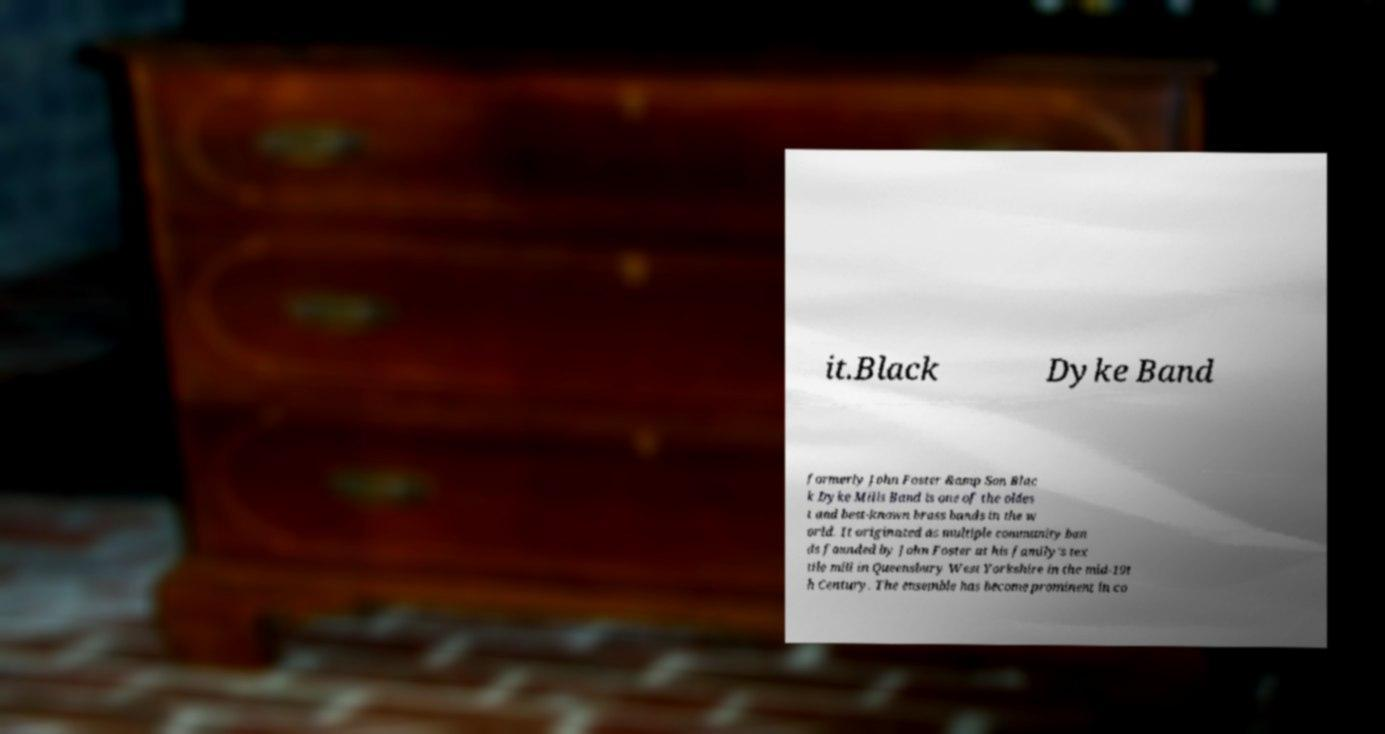There's text embedded in this image that I need extracted. Can you transcribe it verbatim? it.Black Dyke Band formerly John Foster &amp Son Blac k Dyke Mills Band is one of the oldes t and best-known brass bands in the w orld. It originated as multiple community ban ds founded by John Foster at his family's tex tile mill in Queensbury West Yorkshire in the mid-19t h Century. The ensemble has become prominent in co 